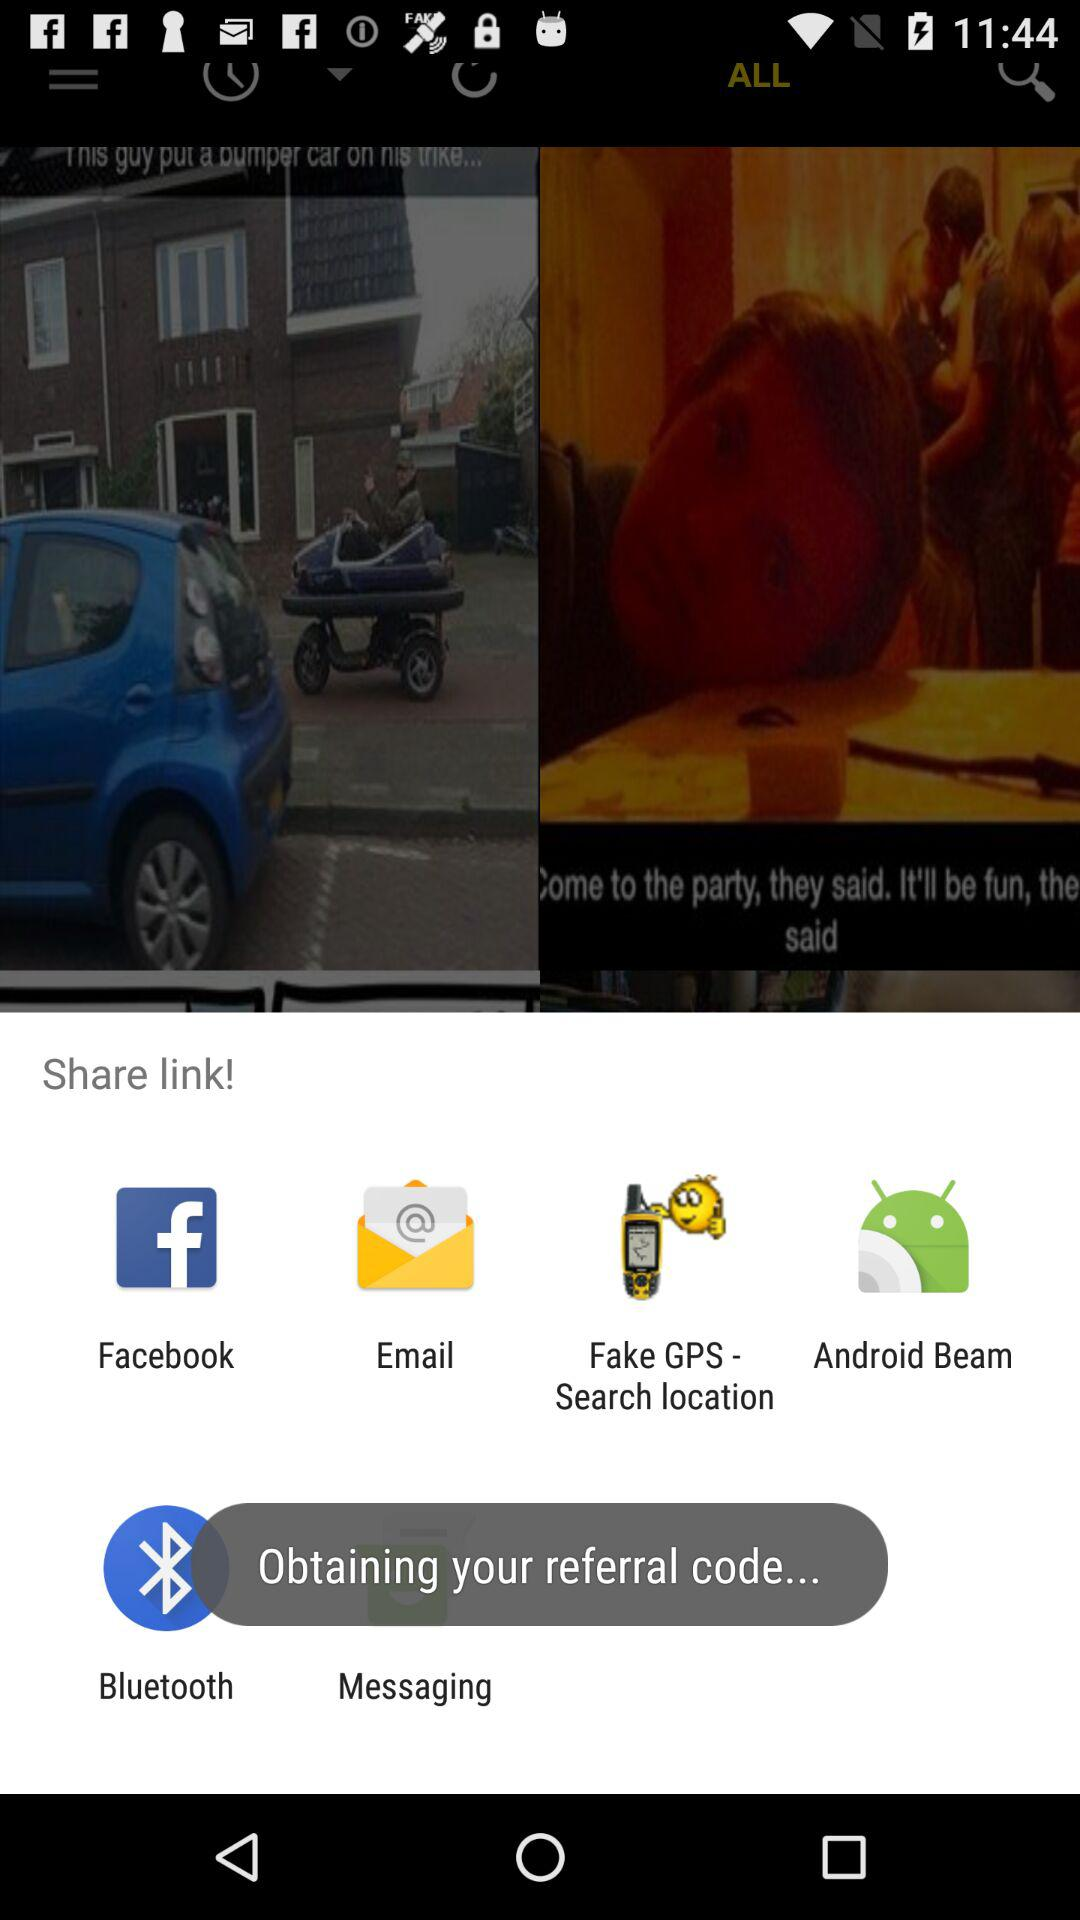What are the apps that can be used to share content? The apps that can be used to share content are "Facebook", "Email", "Fake GPS - Search location", "Android Beam", "Bluetooth" and "Bluetooth". 